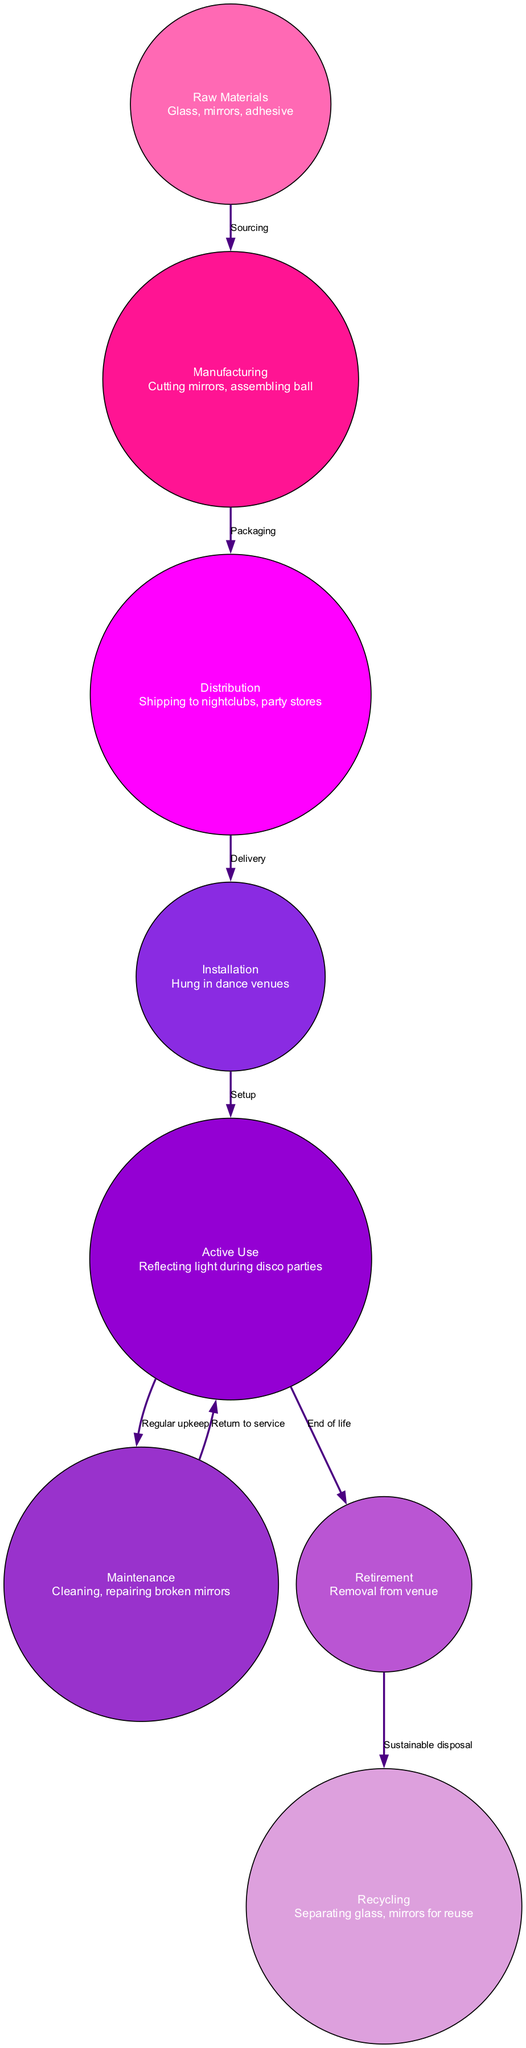What are the raw materials used in the disco ball? The diagram indicates that the raw materials for the disco ball include glass, mirrors, and adhesive as mentioned in the details of the "Raw Materials" node.
Answer: Glass, mirrors, adhesive What stage comes after manufacturing? According to the diagram, the edge that connects the "Manufacturing" node to the "Distribution" node shows that distribution is the next step after manufacturing.
Answer: Distribution How many nodes are in the diagram? By counting the listed nodes in the diagram, there are a total of eight nodes representing different stages of the disco ball lifecycle.
Answer: Eight What is the last stage before recycling? The diagram shows that after the "Retirement" node, the next stage is "Recycling," which is indicated by the edge from retirement to recycling.
Answer: Recycling What type of maintenance is performed on the disco ball? The "Maintenance" node specifies that cleaning and repairing broken mirrors are the key activities performed to keep the disco ball in good condition.
Answer: Cleaning, repairing broken mirrors Which stage involves light reflection during disco parties? The "Active Use" node states that the disco ball reflects light during disco parties, showing its core function during this stage.
Answer: Reflecting light during disco parties What is the relationship between installation and active use? The diagram depicts that after installation, the disco ball is immediately set up to begin its active use during disco parties as shown by the edge labeled "Setup."
Answer: Setup What happens to the disco ball at the end of its life? The "End of life" node points to the "Retirement" stage, indicating that removal from the venue occurs when the disco ball's usable life is over.
Answer: Removal from venue 